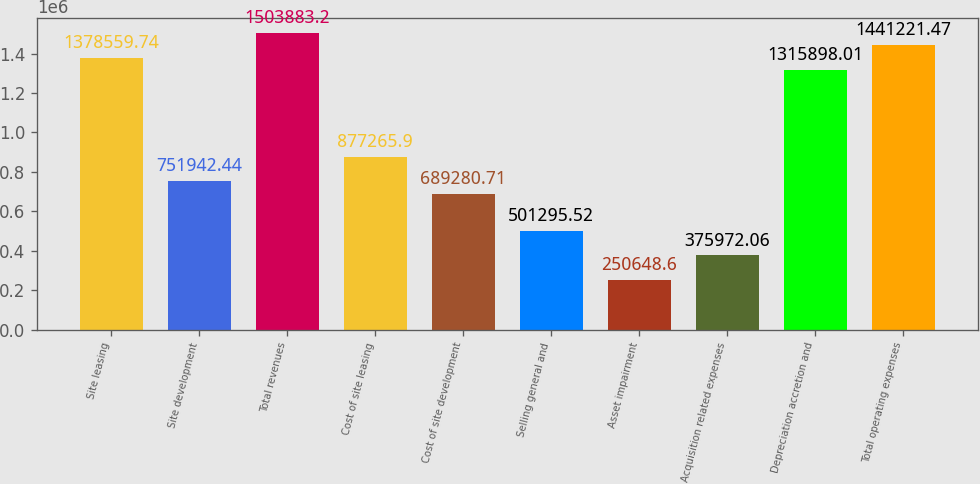<chart> <loc_0><loc_0><loc_500><loc_500><bar_chart><fcel>Site leasing<fcel>Site development<fcel>Total revenues<fcel>Cost of site leasing<fcel>Cost of site development<fcel>Selling general and<fcel>Asset impairment<fcel>Acquisition related expenses<fcel>Depreciation accretion and<fcel>Total operating expenses<nl><fcel>1.37856e+06<fcel>751942<fcel>1.50388e+06<fcel>877266<fcel>689281<fcel>501296<fcel>250649<fcel>375972<fcel>1.3159e+06<fcel>1.44122e+06<nl></chart> 